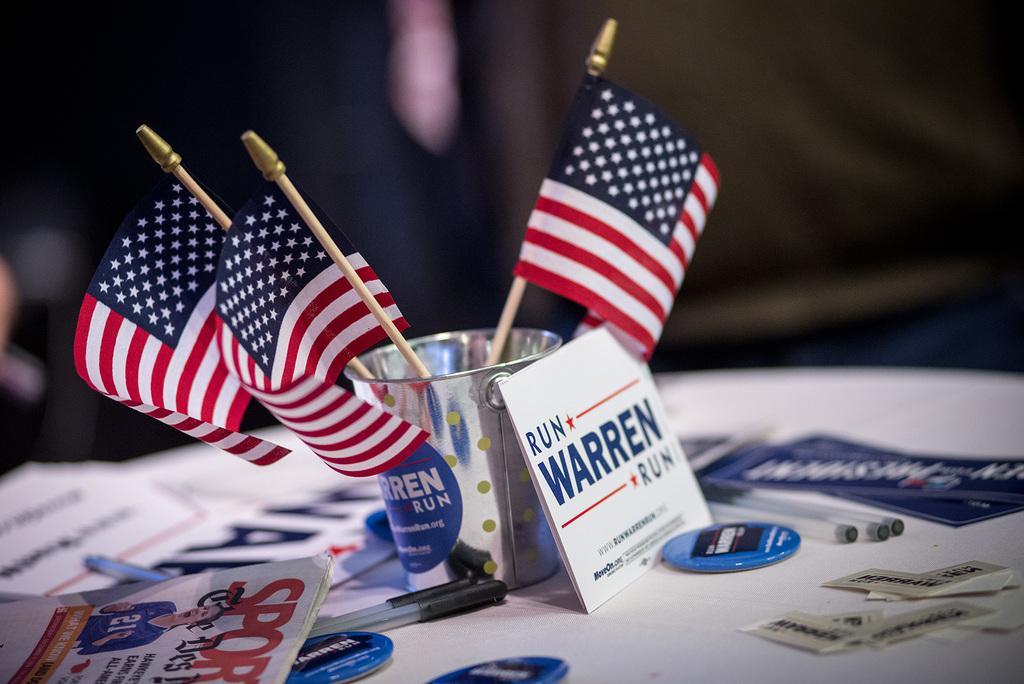Please provide a concise description of this image. In this image, we can see a cup, in that cup there are three small US flags kept, there are some pens and there are some papers on the white color table. 